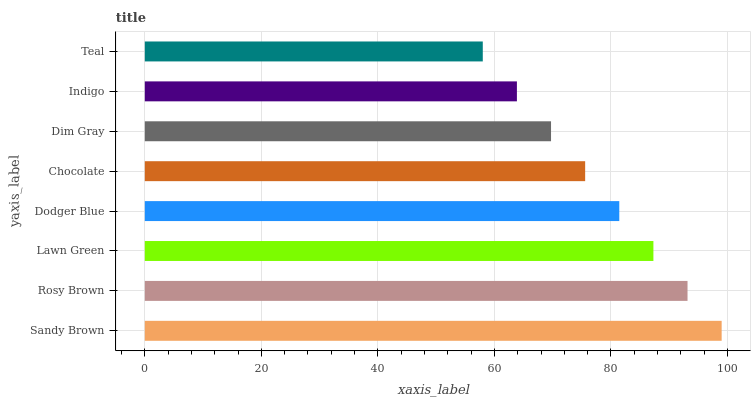Is Teal the minimum?
Answer yes or no. Yes. Is Sandy Brown the maximum?
Answer yes or no. Yes. Is Rosy Brown the minimum?
Answer yes or no. No. Is Rosy Brown the maximum?
Answer yes or no. No. Is Sandy Brown greater than Rosy Brown?
Answer yes or no. Yes. Is Rosy Brown less than Sandy Brown?
Answer yes or no. Yes. Is Rosy Brown greater than Sandy Brown?
Answer yes or no. No. Is Sandy Brown less than Rosy Brown?
Answer yes or no. No. Is Dodger Blue the high median?
Answer yes or no. Yes. Is Chocolate the low median?
Answer yes or no. Yes. Is Dim Gray the high median?
Answer yes or no. No. Is Lawn Green the low median?
Answer yes or no. No. 